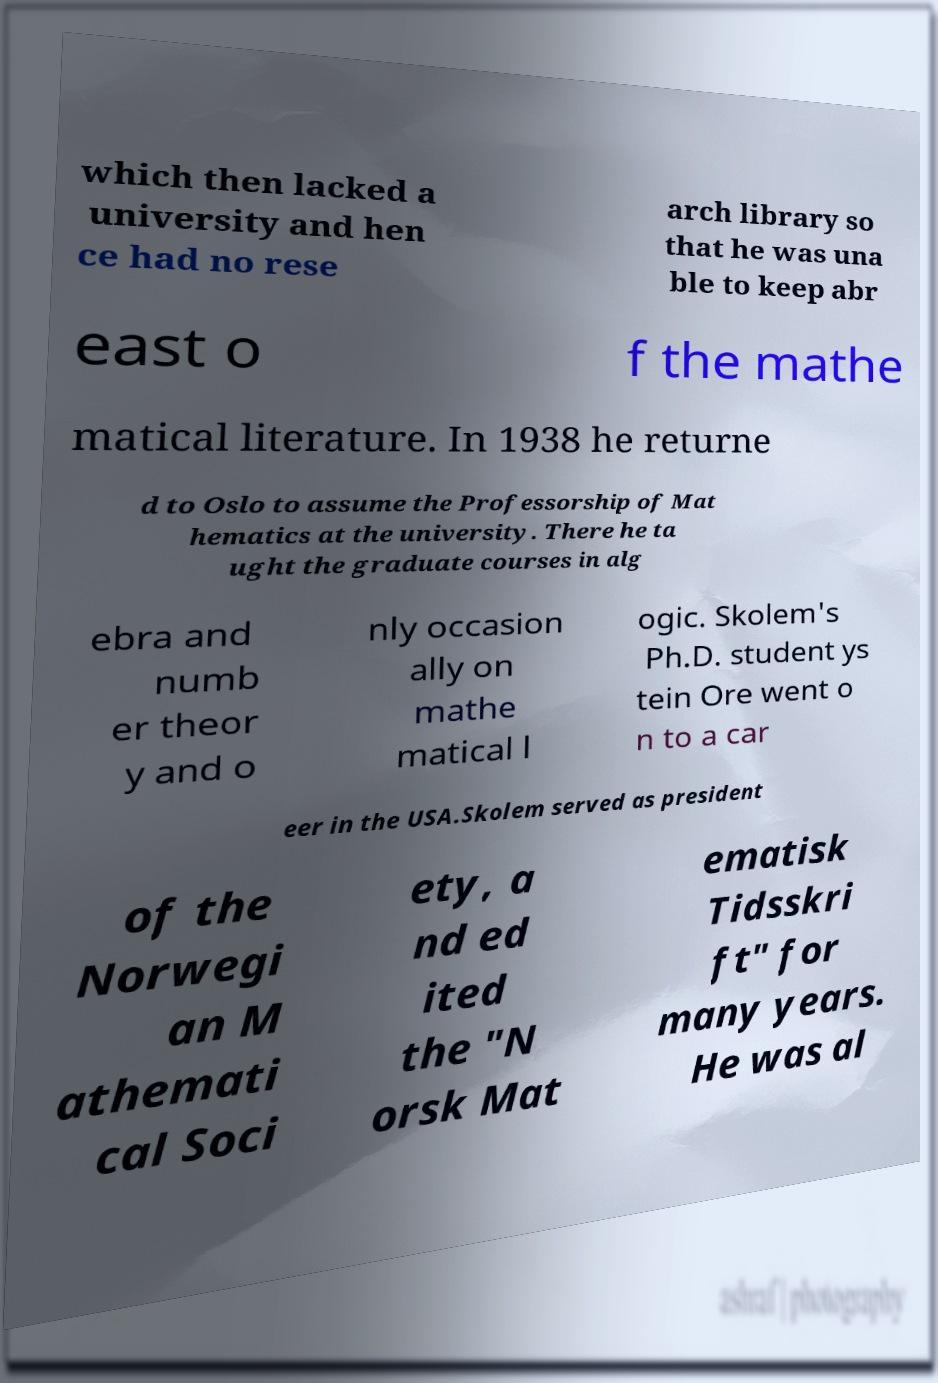For documentation purposes, I need the text within this image transcribed. Could you provide that? which then lacked a university and hen ce had no rese arch library so that he was una ble to keep abr east o f the mathe matical literature. In 1938 he returne d to Oslo to assume the Professorship of Mat hematics at the university. There he ta ught the graduate courses in alg ebra and numb er theor y and o nly occasion ally on mathe matical l ogic. Skolem's Ph.D. student ys tein Ore went o n to a car eer in the USA.Skolem served as president of the Norwegi an M athemati cal Soci ety, a nd ed ited the "N orsk Mat ematisk Tidsskri ft" for many years. He was al 